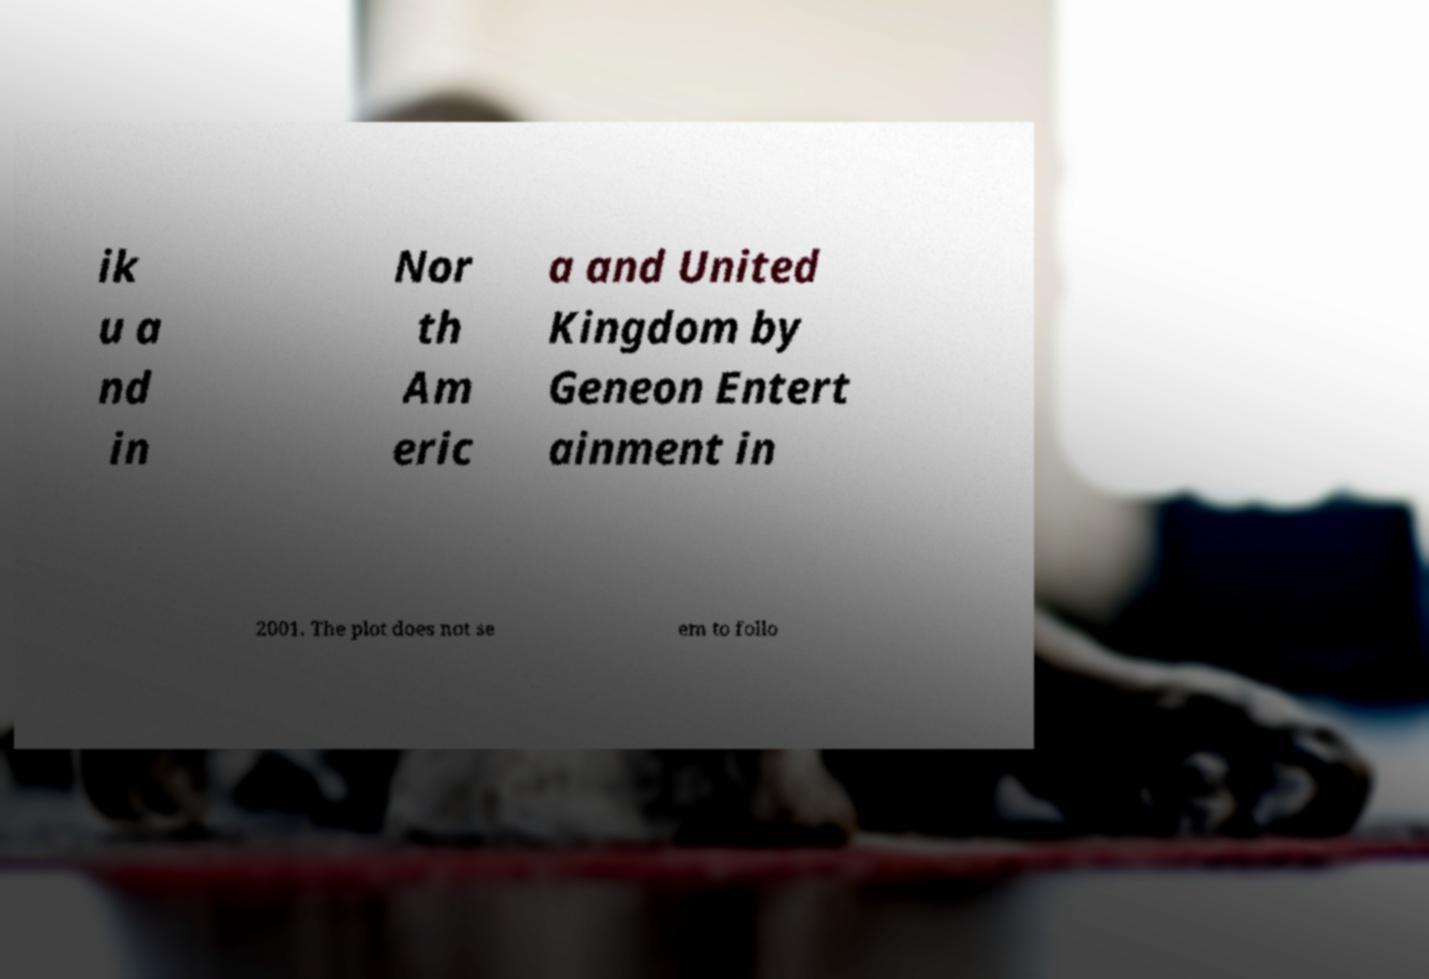Please read and relay the text visible in this image. What does it say? ik u a nd in Nor th Am eric a and United Kingdom by Geneon Entert ainment in 2001. The plot does not se em to follo 